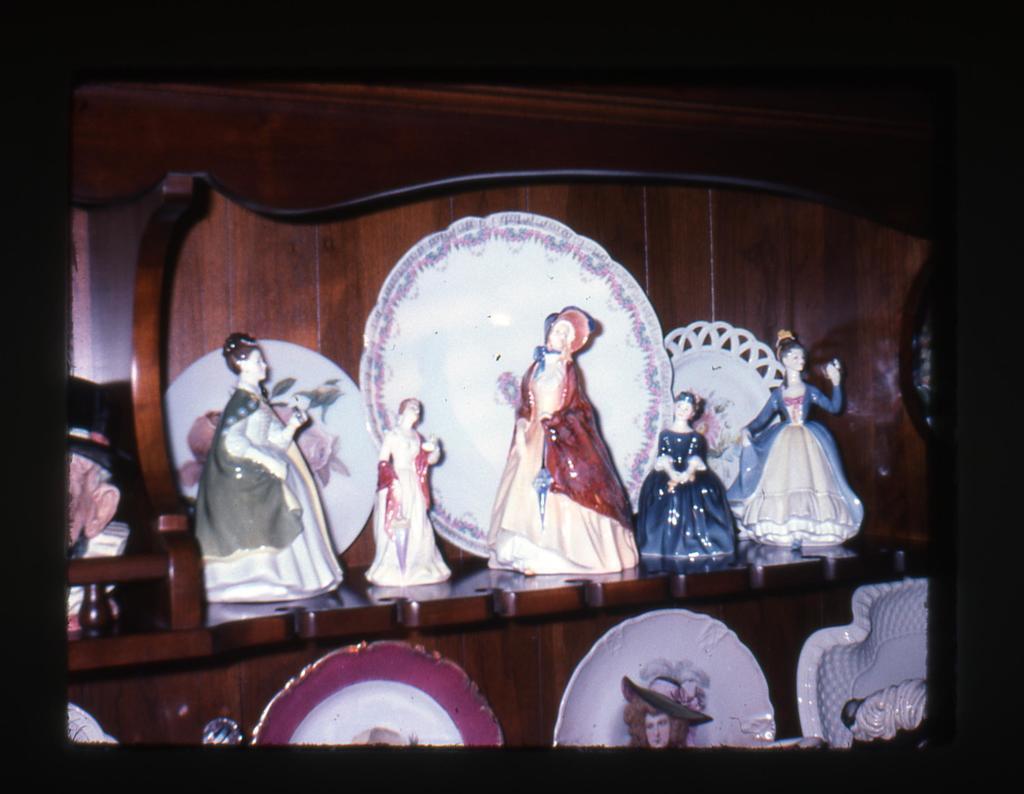In one or two sentences, can you explain what this image depicts? In this image, we can see there are plates and statues arranged on the shelves. And the background is dark in color. 